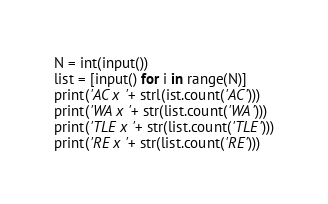<code> <loc_0><loc_0><loc_500><loc_500><_Python_>N = int(input())
list = [input() for i in range(N)]
print('AC x '+ strl(ist.count('AC')))
print('WA x '+ str(list.count('WA')))
print('TLE x '+ str(list.count('TLE')))
print('RE x '+ str(list.count('RE')))</code> 